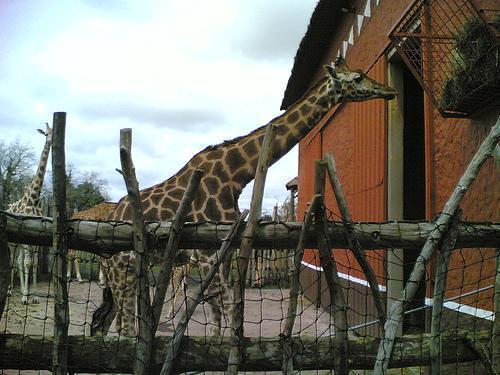How many giraffes are there?
Give a very brief answer. 2. 